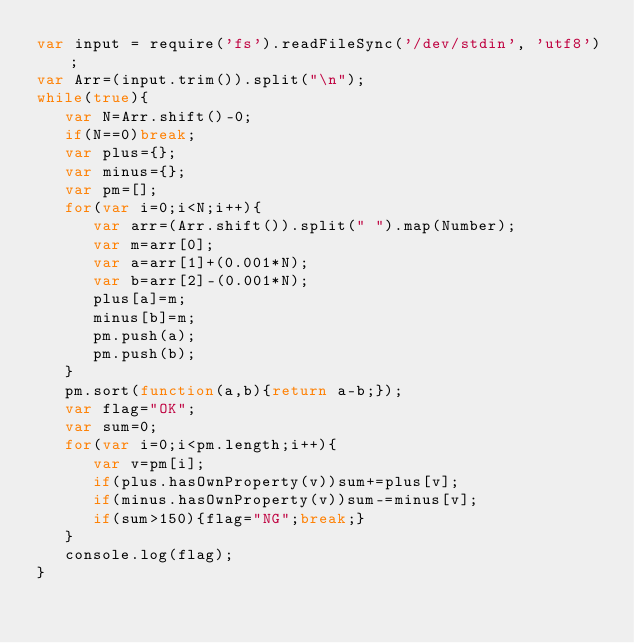<code> <loc_0><loc_0><loc_500><loc_500><_JavaScript_>var input = require('fs').readFileSync('/dev/stdin', 'utf8');
var Arr=(input.trim()).split("\n");
while(true){
   var N=Arr.shift()-0;
   if(N==0)break;
   var plus={};
   var minus={};
   var pm=[];
   for(var i=0;i<N;i++){
      var arr=(Arr.shift()).split(" ").map(Number);
      var m=arr[0];
      var a=arr[1]+(0.001*N);
      var b=arr[2]-(0.001*N);
      plus[a]=m;
      minus[b]=m;
      pm.push(a);
      pm.push(b);
   }
   pm.sort(function(a,b){return a-b;});
   var flag="OK";
   var sum=0;
   for(var i=0;i<pm.length;i++){
      var v=pm[i];
      if(plus.hasOwnProperty(v))sum+=plus[v];
      if(minus.hasOwnProperty(v))sum-=minus[v];
      if(sum>150){flag="NG";break;}
   }
   console.log(flag);
}</code> 